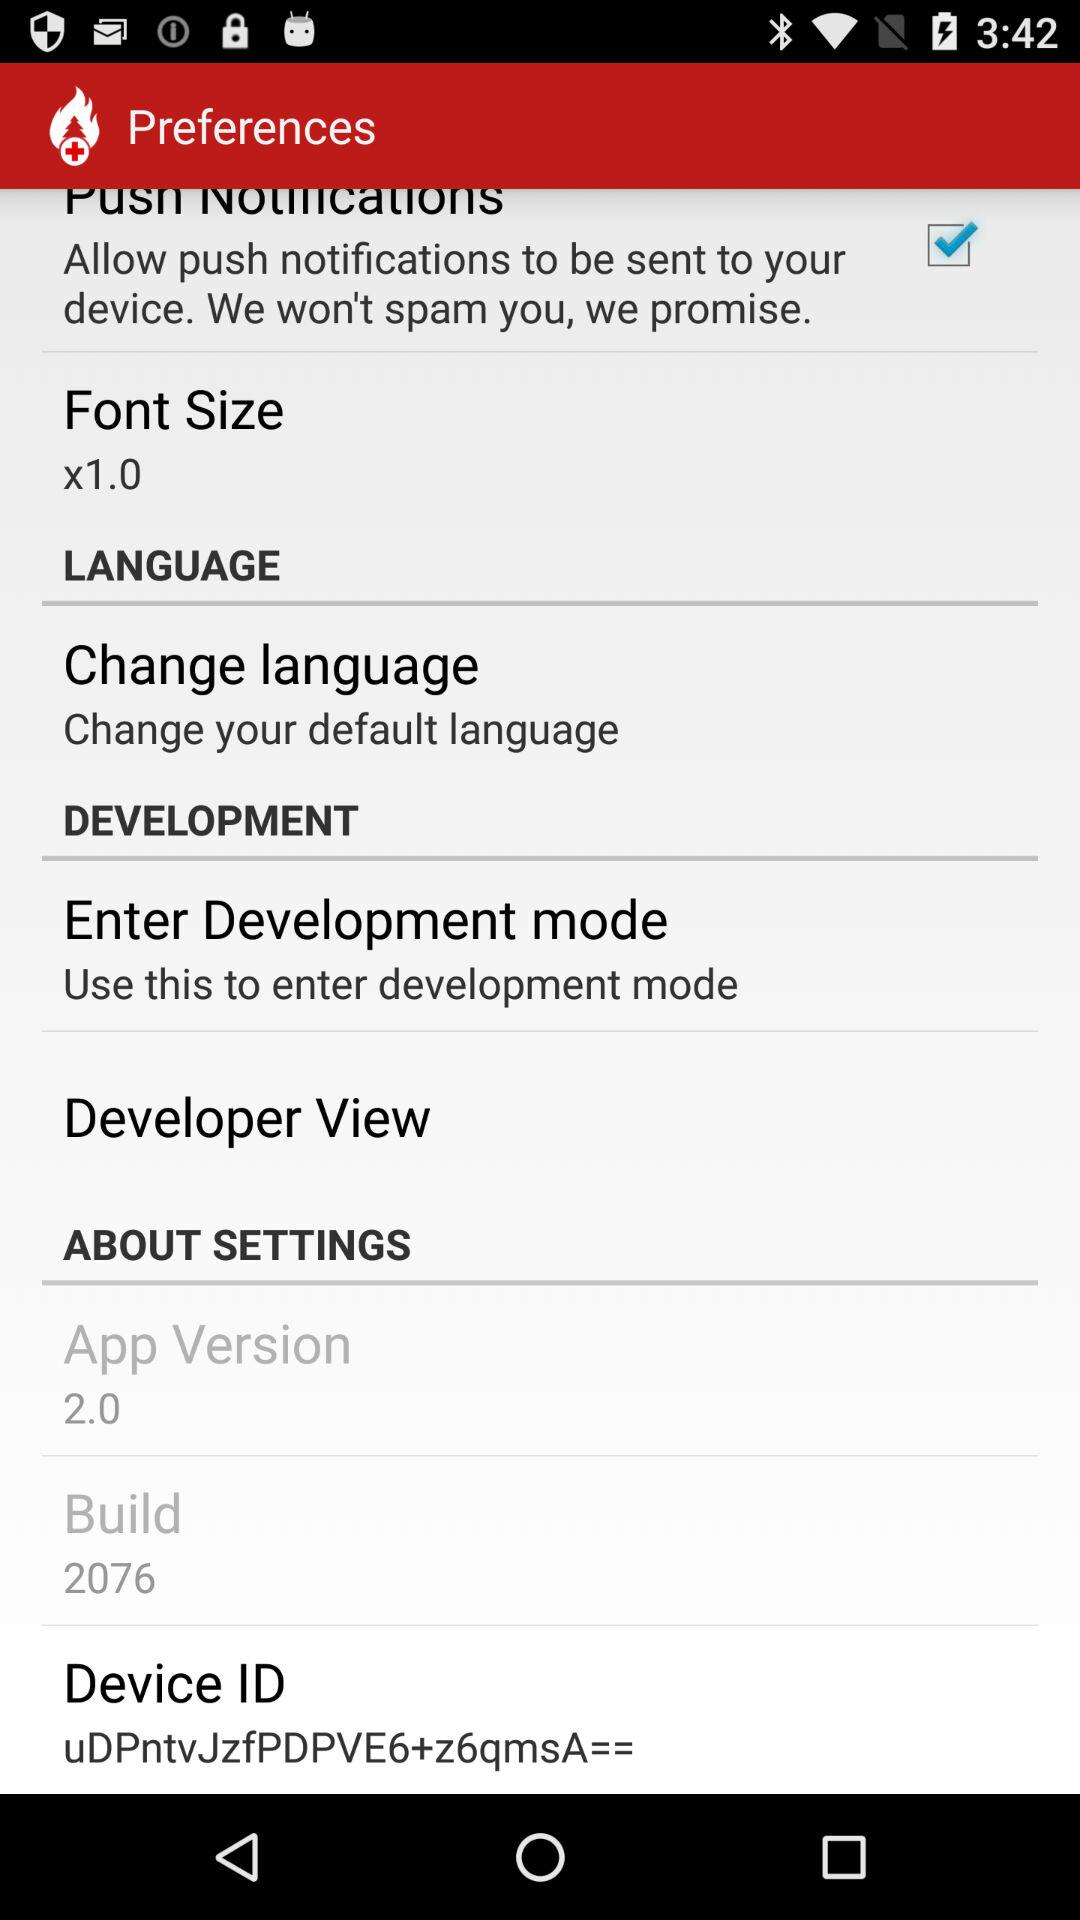What is the font size? The font size is "x1.0". 